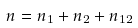<formula> <loc_0><loc_0><loc_500><loc_500>n = n _ { 1 } + n _ { 2 } + n _ { 1 2 }</formula> 